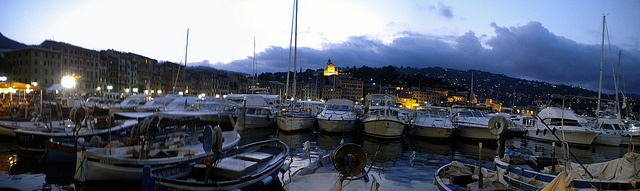Describe the objects in this image and their specific colors. I can see boat in lightblue, black, navy, and gray tones, boat in lightblue, black, and gray tones, boat in lightblue, black, gray, navy, and darkblue tones, boat in lightblue, black, and gray tones, and boat in lightblue, black, and gray tones in this image. 